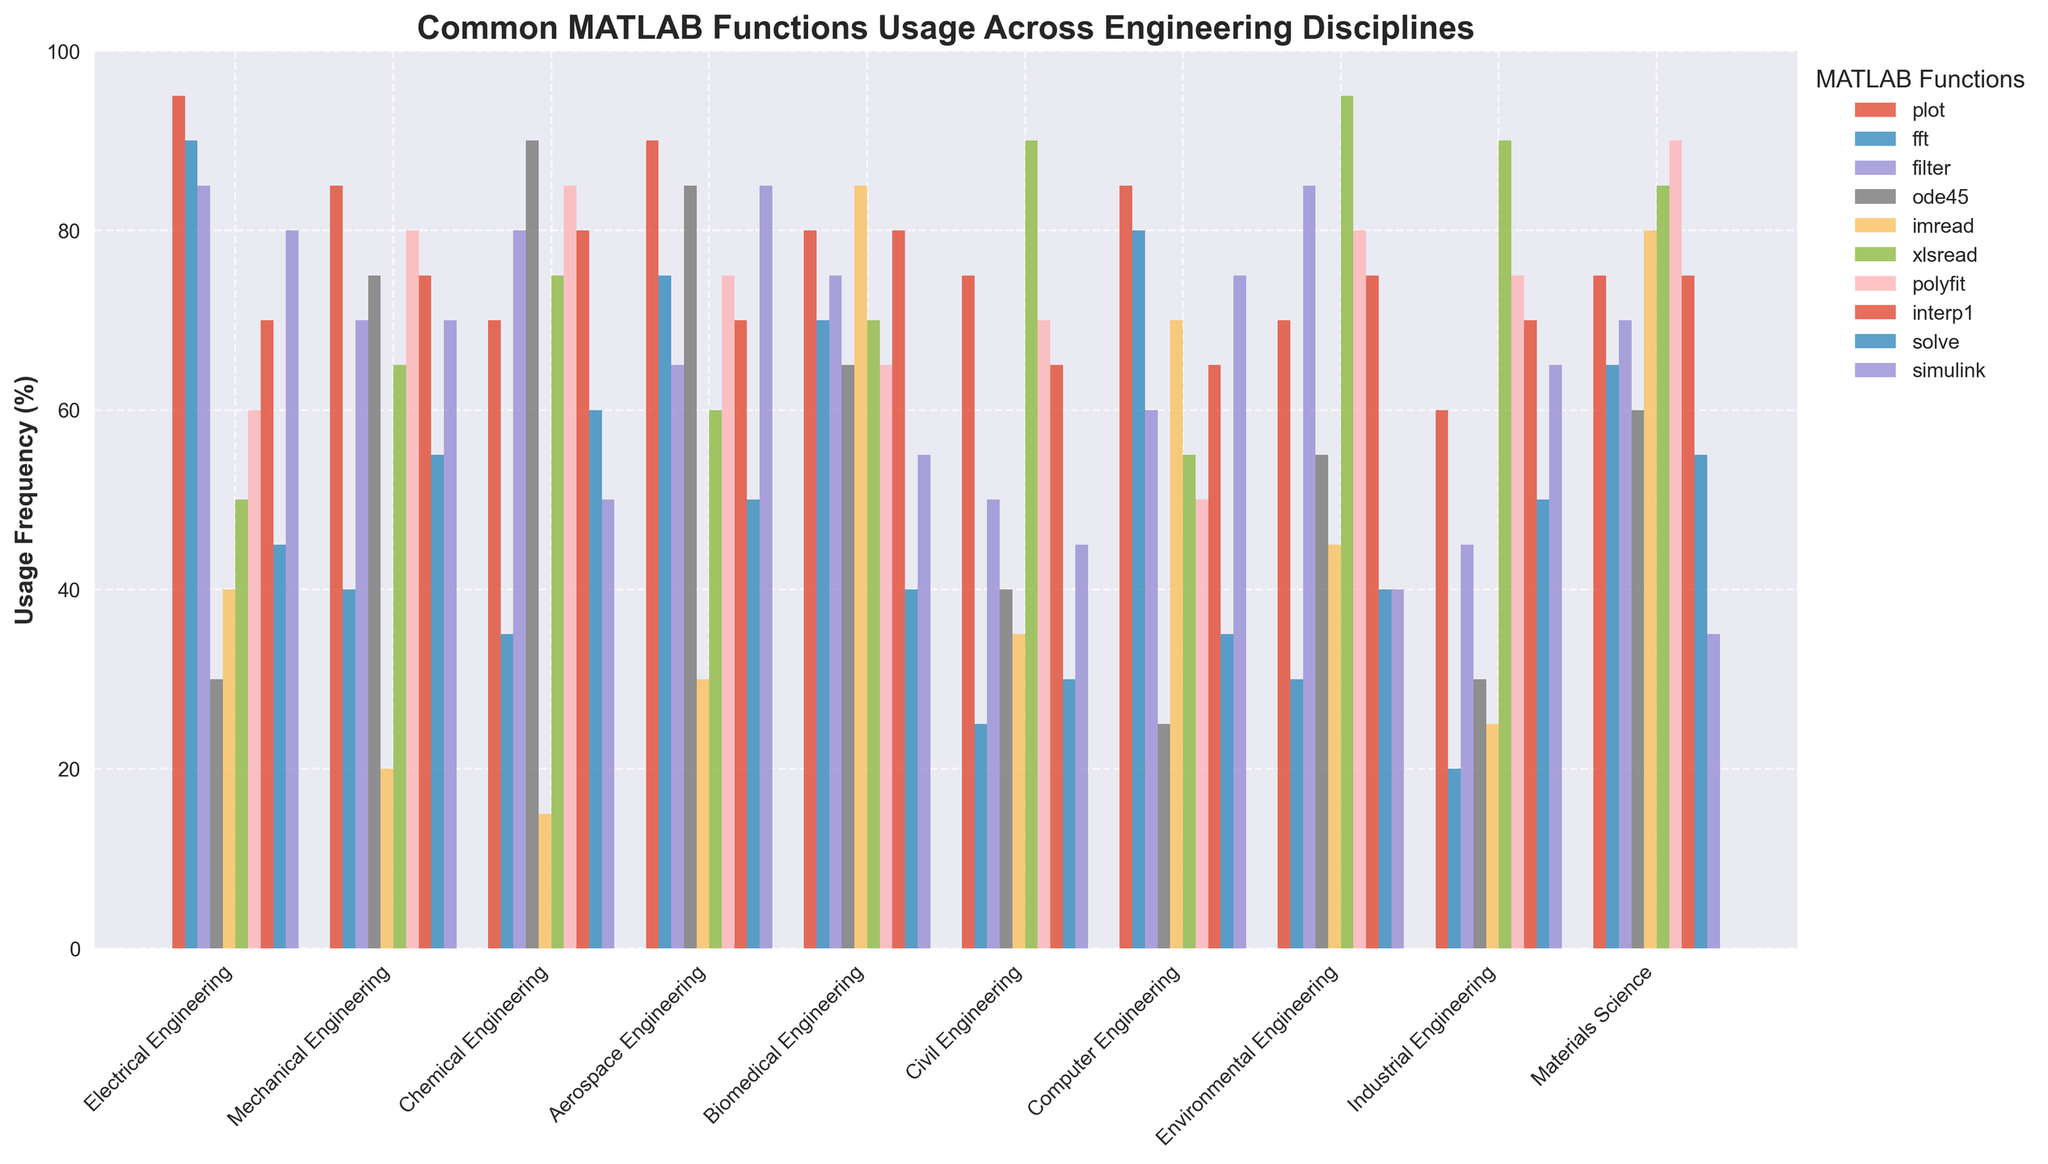Which engineering discipline uses the `plot` function the most? By looking at the heights of the bars representing the `plot` function, Electrical Engineering has the tallest bar, indicating the highest usage frequency.
Answer: Electrical Engineering Which MATLAB function is least used in Electrical Engineering? Compare the heights of the bars for Electrical Engineering. The `ode45` function has the lowest bar.
Answer: ode45 What is the average usage frequency of the `imread` function across all disciplines? Sum the usage frequencies of `imread` across all engineering disciplines and divide by the number of disciplines: (40 + 20 + 15 + 30 + 85 + 35 + 70 + 45 + 25 + 80) / 10 = 44.5%.
Answer: 44.5% Which functions have the same usage frequency in Civil Engineering? Look at the heights of the bars for Civil Engineering and identify which ones are equal. The `imread` and `solve` functions both show frequencies of 35%.
Answer: imread, solve Compared to Electrical Engineering and Mechanical Engineering, which discipline uses the `interp1` function more? Observe the `interp1` bars for the three disciplines. Mechanical Engineering uses `interp1` more (75%) compared to Electrical Engineering (70%) and the same as Aerospace Engineering (70%).
Answer: Aerospace Engineering How much higher is the usage of the `simulink` function in Aerospace Engineering compared to Industrial Engineering? Subtract the usage frequency of `simulink` in Industrial Engineering from that in Aerospace Engineering: 85 - 65 = 20%.
Answer: 20% Which engineering discipline shows the highest usage of the `xlsread` function? Identify the tallest `xlsread` bar across all disciplines. Environmental Engineering has the tallest bar at 95%.
Answer: Environmental Engineering What are the disciplines where the usage frequency of `fft` is above 70%? Find the disciplines where the `fft` bar is higher than 70%. These include Electrical Engineering (90%), Aerospace Engineering (75%), Biomedical Engineering (70%), and Computer Engineering (80%).
Answer: Electrical Engineering, Aerospace Engineering, Biomedical Engineering, Computer Engineering Which MATLAB function has the same usage frequency in Biomedical Engineering and Civil Engineering? Compare the heights of the bars for each function between Biomedical and Civil Engineering. The `interp1` function shows identical usage frequencies (65%) in both disciplines.
Answer: interp1 What’s the total usage frequency of the `ode45` function across all disciplines? Sum the `ode45` usage frequencies across all disciplines: 30 + 75 + 90 + 85 + 65 + 40 + 25 + 55 + 30 + 60 = 555%.
Answer: 555% 